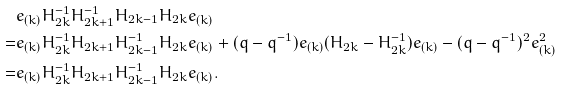Convert formula to latex. <formula><loc_0><loc_0><loc_500><loc_500>& e _ { ( k ) } H _ { 2 k } ^ { - 1 } H _ { 2 k + 1 } ^ { - 1 } H _ { 2 k - 1 } H _ { 2 k } e _ { ( k ) } \\ = & e _ { ( k ) } H _ { 2 k } ^ { - 1 } H _ { 2 k + 1 } H _ { 2 k - 1 } ^ { - 1 } H _ { 2 k } e _ { ( k ) } + ( q - q ^ { - 1 } ) e _ { ( k ) } ( H _ { 2 k } - H _ { 2 k } ^ { - 1 } ) e _ { ( k ) } - ( q - q ^ { - 1 } ) ^ { 2 } e _ { ( k ) } ^ { 2 } \\ = & e _ { ( k ) } H _ { 2 k } ^ { - 1 } H _ { 2 k + 1 } H _ { 2 k - 1 } ^ { - 1 } H _ { 2 k } e _ { ( k ) } .</formula> 